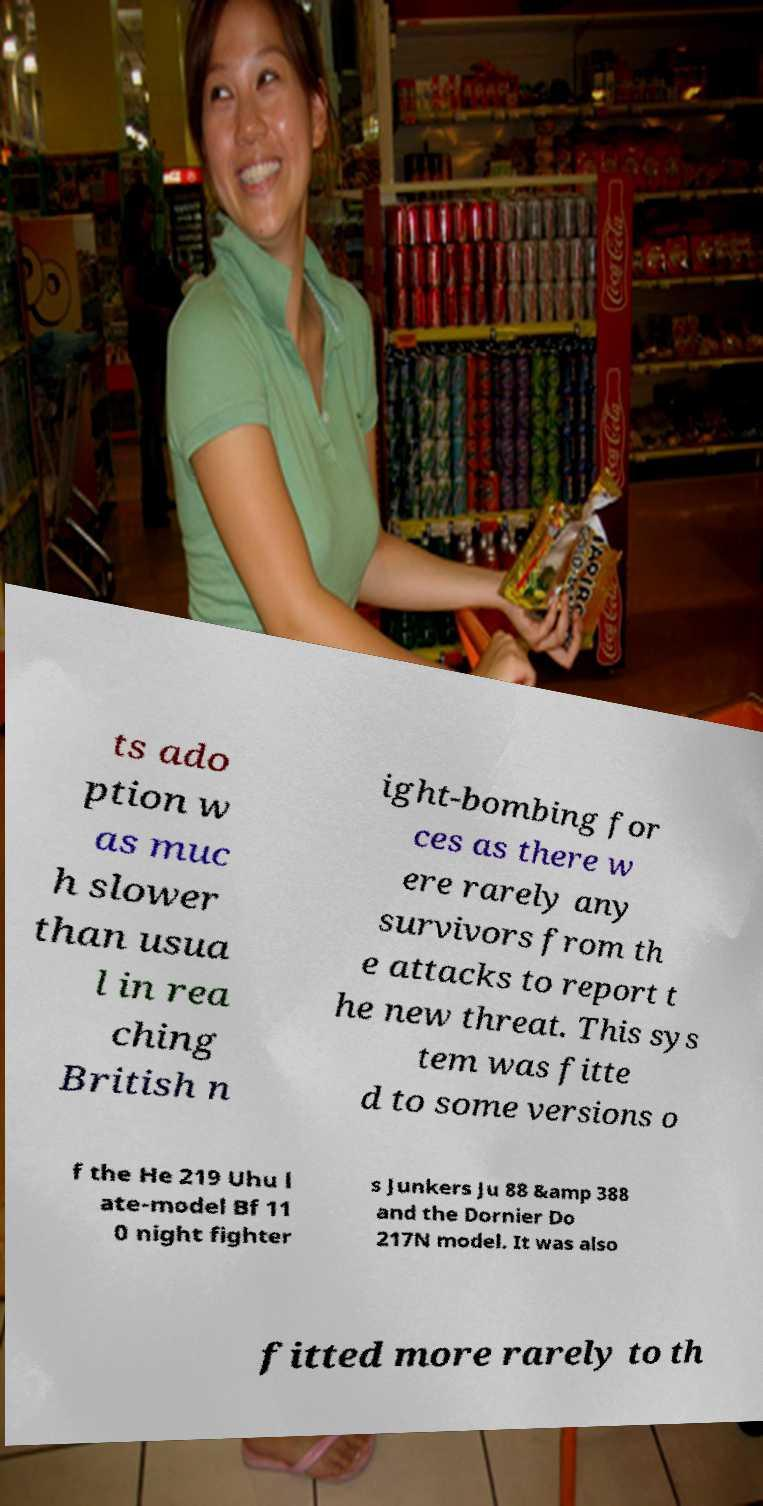Could you assist in decoding the text presented in this image and type it out clearly? ts ado ption w as muc h slower than usua l in rea ching British n ight-bombing for ces as there w ere rarely any survivors from th e attacks to report t he new threat. This sys tem was fitte d to some versions o f the He 219 Uhu l ate-model Bf 11 0 night fighter s Junkers Ju 88 &amp 388 and the Dornier Do 217N model. It was also fitted more rarely to th 